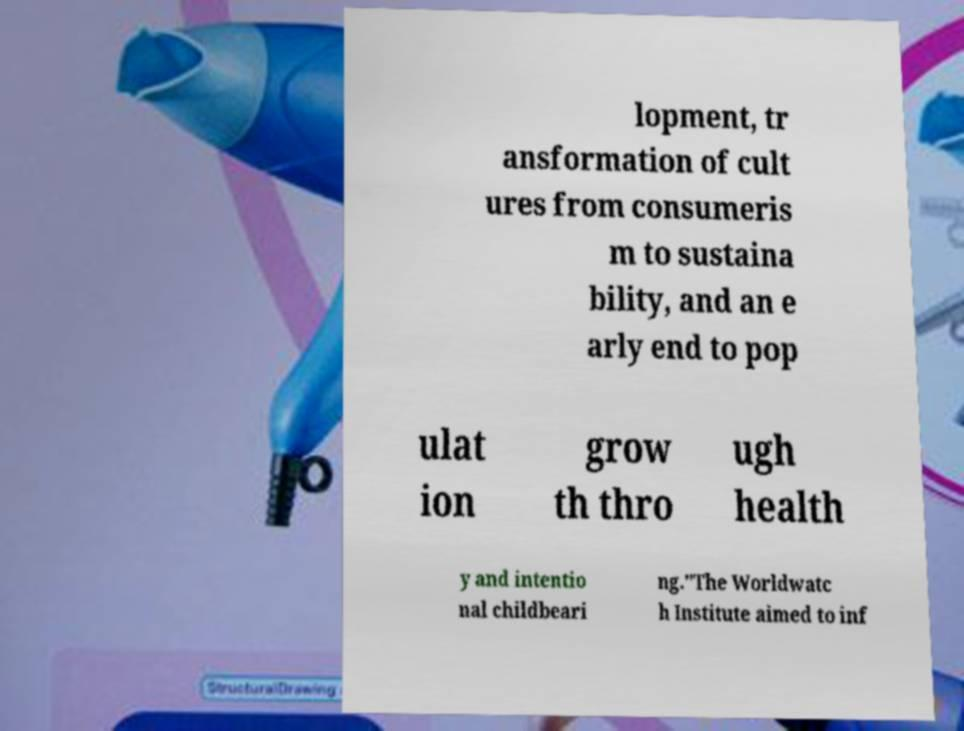Could you extract and type out the text from this image? lopment, tr ansformation of cult ures from consumeris m to sustaina bility, and an e arly end to pop ulat ion grow th thro ugh health y and intentio nal childbeari ng."The Worldwatc h Institute aimed to inf 